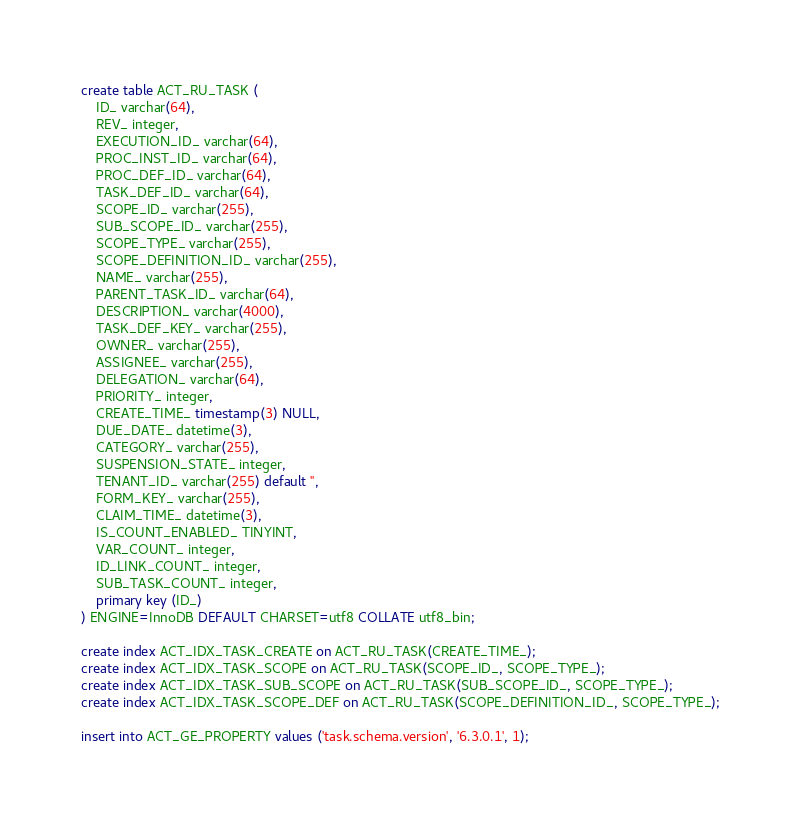<code> <loc_0><loc_0><loc_500><loc_500><_SQL_>create table ACT_RU_TASK (
    ID_ varchar(64),
    REV_ integer,
    EXECUTION_ID_ varchar(64),
    PROC_INST_ID_ varchar(64),
    PROC_DEF_ID_ varchar(64),
    TASK_DEF_ID_ varchar(64),
    SCOPE_ID_ varchar(255),
    SUB_SCOPE_ID_ varchar(255),
    SCOPE_TYPE_ varchar(255),
    SCOPE_DEFINITION_ID_ varchar(255),
    NAME_ varchar(255),
    PARENT_TASK_ID_ varchar(64),
    DESCRIPTION_ varchar(4000),
    TASK_DEF_KEY_ varchar(255),
    OWNER_ varchar(255),
    ASSIGNEE_ varchar(255),
    DELEGATION_ varchar(64),
    PRIORITY_ integer,
    CREATE_TIME_ timestamp(3) NULL,
    DUE_DATE_ datetime(3),
    CATEGORY_ varchar(255),
    SUSPENSION_STATE_ integer,
    TENANT_ID_ varchar(255) default '',
    FORM_KEY_ varchar(255),
    CLAIM_TIME_ datetime(3),
    IS_COUNT_ENABLED_ TINYINT,
    VAR_COUNT_ integer,
    ID_LINK_COUNT_ integer,
    SUB_TASK_COUNT_ integer,
    primary key (ID_)
) ENGINE=InnoDB DEFAULT CHARSET=utf8 COLLATE utf8_bin;

create index ACT_IDX_TASK_CREATE on ACT_RU_TASK(CREATE_TIME_);
create index ACT_IDX_TASK_SCOPE on ACT_RU_TASK(SCOPE_ID_, SCOPE_TYPE_);
create index ACT_IDX_TASK_SUB_SCOPE on ACT_RU_TASK(SUB_SCOPE_ID_, SCOPE_TYPE_);
create index ACT_IDX_TASK_SCOPE_DEF on ACT_RU_TASK(SCOPE_DEFINITION_ID_, SCOPE_TYPE_);

insert into ACT_GE_PROPERTY values ('task.schema.version', '6.3.0.1', 1);</code> 